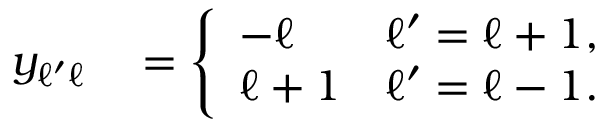<formula> <loc_0><loc_0><loc_500><loc_500>\begin{array} { r l } { y _ { \ell ^ { \prime } \ell } } & = \left \{ \begin{array} { l l } { - \ell } & { \ell ^ { \prime } = \ell + 1 , } \\ { \ell + 1 } & { \ell ^ { \prime } = \ell - 1 . } \end{array} } \end{array}</formula> 